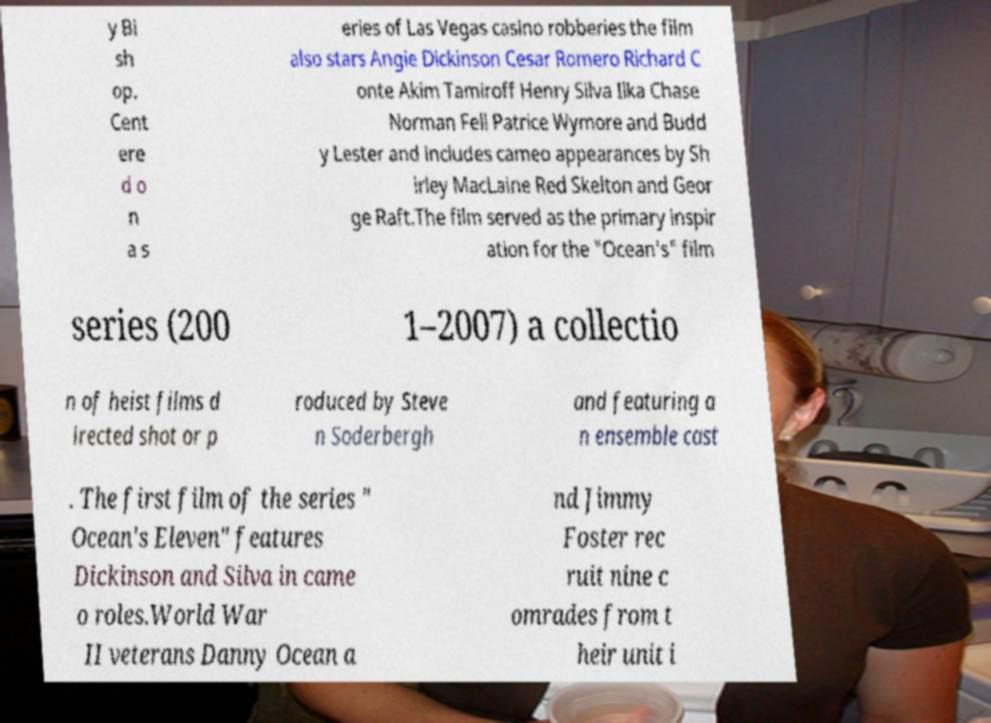For documentation purposes, I need the text within this image transcribed. Could you provide that? y Bi sh op. Cent ere d o n a s eries of Las Vegas casino robberies the film also stars Angie Dickinson Cesar Romero Richard C onte Akim Tamiroff Henry Silva Ilka Chase Norman Fell Patrice Wymore and Budd y Lester and includes cameo appearances by Sh irley MacLaine Red Skelton and Geor ge Raft.The film served as the primary inspir ation for the "Ocean's" film series (200 1–2007) a collectio n of heist films d irected shot or p roduced by Steve n Soderbergh and featuring a n ensemble cast . The first film of the series " Ocean's Eleven" features Dickinson and Silva in came o roles.World War II veterans Danny Ocean a nd Jimmy Foster rec ruit nine c omrades from t heir unit i 